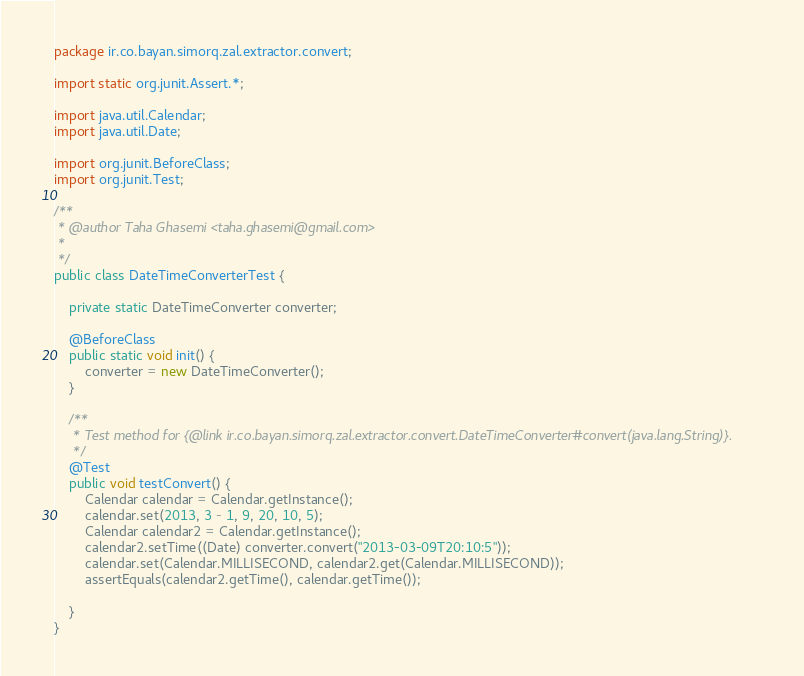<code> <loc_0><loc_0><loc_500><loc_500><_Java_>package ir.co.bayan.simorq.zal.extractor.convert;

import static org.junit.Assert.*;

import java.util.Calendar;
import java.util.Date;

import org.junit.BeforeClass;
import org.junit.Test;

/**
 * @author Taha Ghasemi <taha.ghasemi@gmail.com>
 * 
 */
public class DateTimeConverterTest {

	private static DateTimeConverter converter;

	@BeforeClass
	public static void init() {
		converter = new DateTimeConverter();
	}

	/**
	 * Test method for {@link ir.co.bayan.simorq.zal.extractor.convert.DateTimeConverter#convert(java.lang.String)}.
	 */
	@Test
	public void testConvert() {
		Calendar calendar = Calendar.getInstance();
		calendar.set(2013, 3 - 1, 9, 20, 10, 5);
		Calendar calendar2 = Calendar.getInstance();
		calendar2.setTime((Date) converter.convert("2013-03-09T20:10:5"));
		calendar.set(Calendar.MILLISECOND, calendar2.get(Calendar.MILLISECOND));
		assertEquals(calendar2.getTime(), calendar.getTime());

	}
}
</code> 